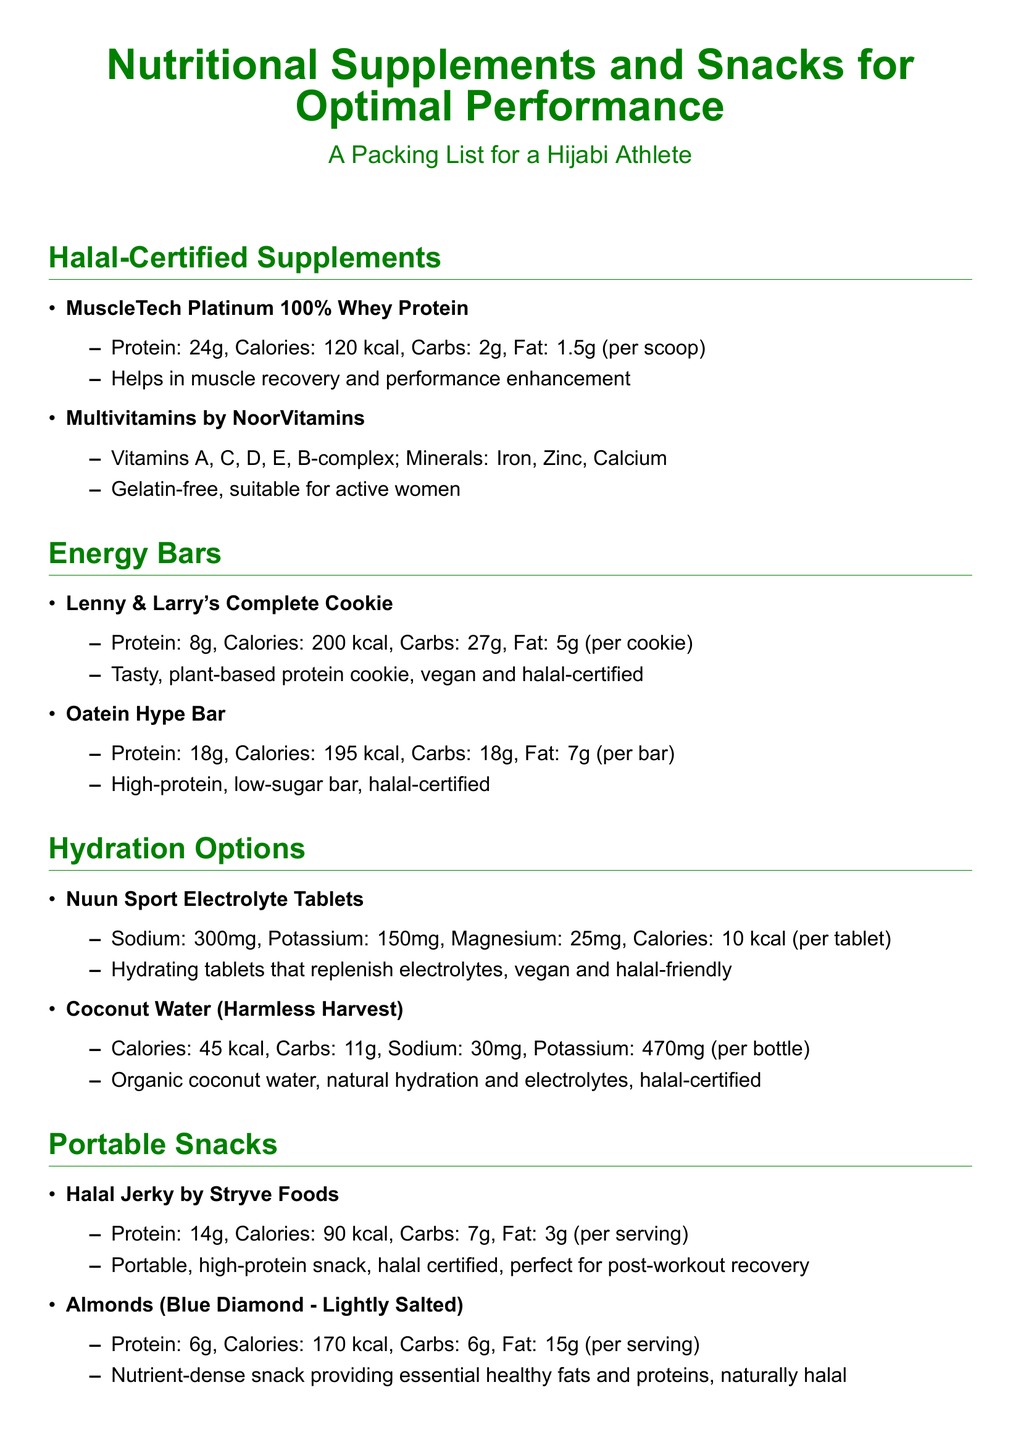What is the protein content in MuscleTech Platinum 100% Whey Protein? The protein content is stated in the document as 24g per scoop.
Answer: 24g How many calories are in the Oatein Hype Bar? The document specifies that the Oatein Hype Bar contains 195 kcal per bar.
Answer: 195 kcal What vitamins are included in the Multivitamins by NoorVitamins? The document lists Vitamins A, C, D, E, and B-complex as the vitamins included.
Answer: A, C, D, E, B-complex What is the fat content of Lenny & Larry's Complete Cookie? The document states that the fat content is 5g per cookie.
Answer: 5g Which product provides high amounts of potassium? The Coconut Water (Harmless Harvest) is highlighted in the document for having 470mg of potassium.
Answer: Coconut Water (Harmless Harvest) How many electrolytes does Nuun Sport Electrolyte Tablets replenish? The document provides information about various electrolytes: Sodium, Potassium, and Magnesium.
Answer: Sodium, Potassium, Magnesium What type of snack is Halal Jerky by Stryve Foods? The document categorizes Halal Jerky as a portable, high-protein snack.
Answer: Portable, high-protein snack Which energy bar is vegan and halal-certified? The document indicates that Lenny & Larry's Complete Cookie is both vegan and halal-certified.
Answer: Lenny & Larry's Complete Cookie What is the total carbohydrates in Almonds by Blue Diamond? The document mentions that the total carbohydrates are 6g per serving.
Answer: 6g 